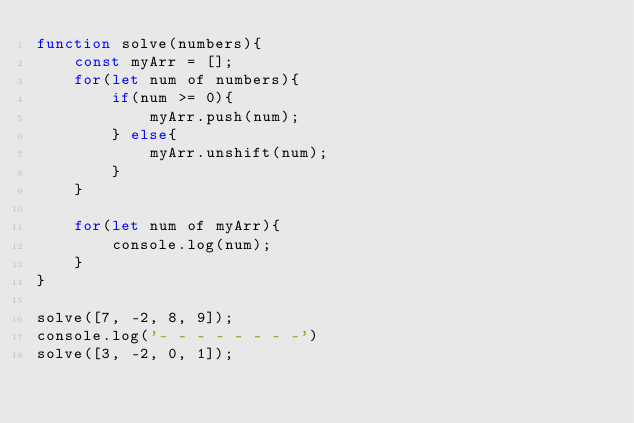<code> <loc_0><loc_0><loc_500><loc_500><_JavaScript_>function solve(numbers){
    const myArr = [];
    for(let num of numbers){
        if(num >= 0){
            myArr.push(num);
        } else{
            myArr.unshift(num);
        }
    }

    for(let num of myArr){
        console.log(num);
    }
}

solve([7, -2, 8, 9]);
console.log('- - - - - - - -')
solve([3, -2, 0, 1]);</code> 